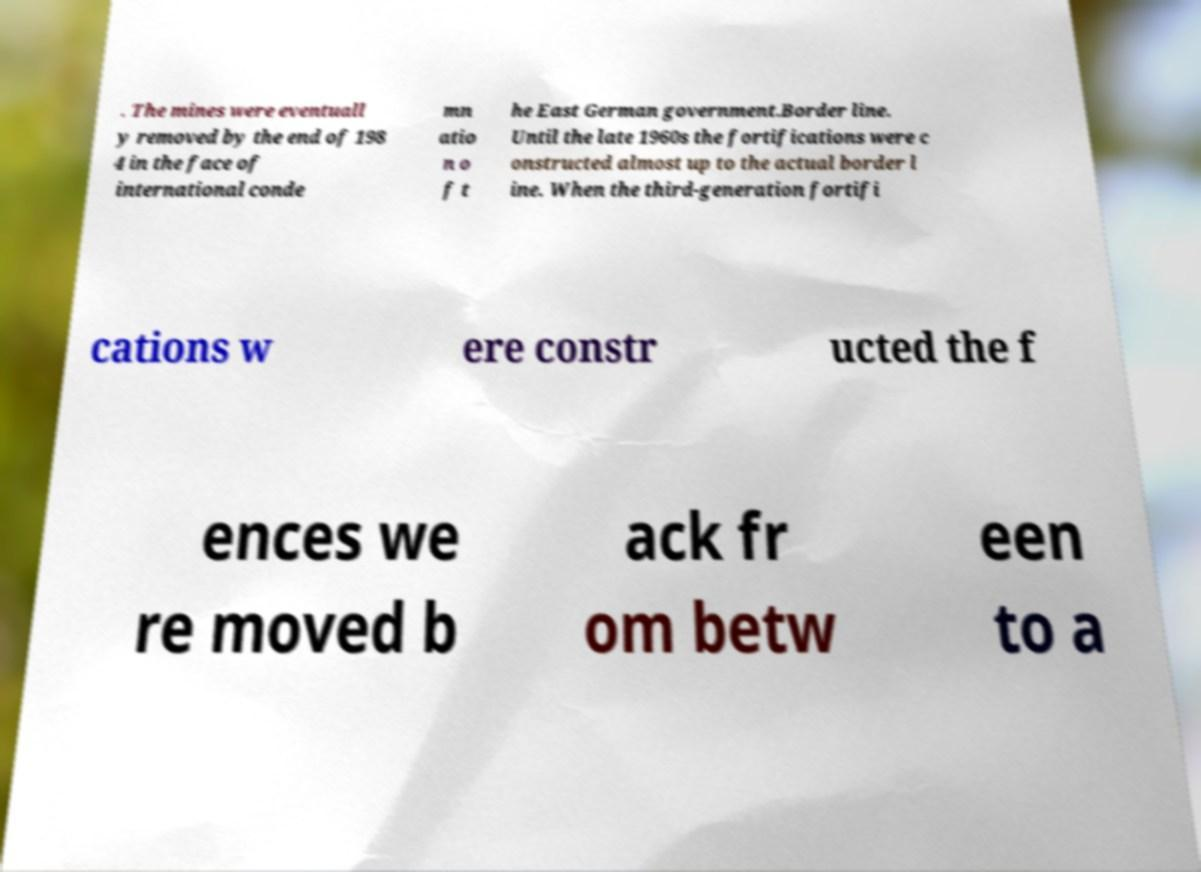There's text embedded in this image that I need extracted. Can you transcribe it verbatim? . The mines were eventuall y removed by the end of 198 4 in the face of international conde mn atio n o f t he East German government.Border line. Until the late 1960s the fortifications were c onstructed almost up to the actual border l ine. When the third-generation fortifi cations w ere constr ucted the f ences we re moved b ack fr om betw een to a 